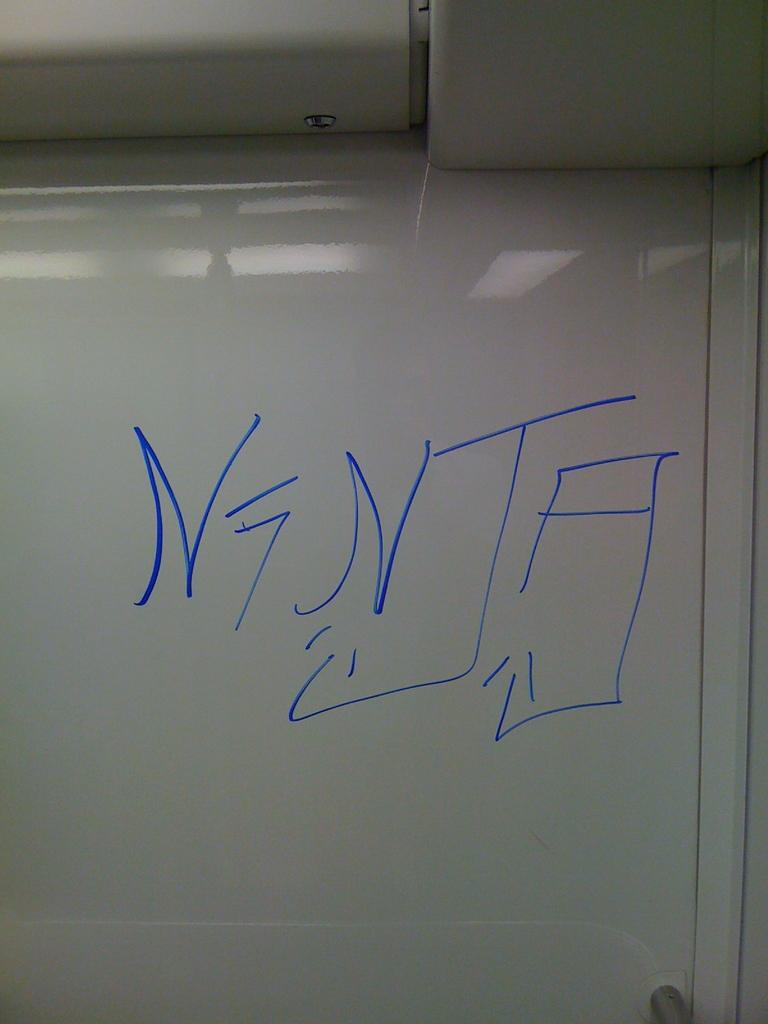Provide a one-sentence caption for the provided image. A classroom white board with large blue lettering with the writing "Nenta.". 